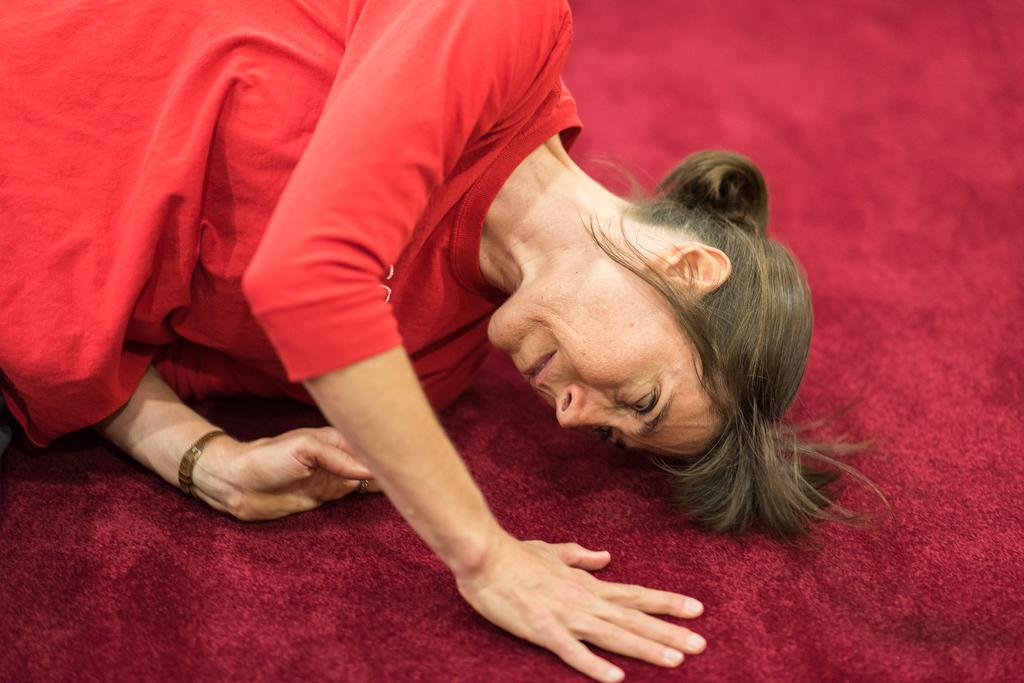Who is present in the image? There is a woman in the image. What is the woman lying on? The woman is lying on a red color mat. What is the woman wearing? The woman is wearing a red color dress. How many roses can be seen in the woman's hair in the image? There are no roses visible in the woman's hair in the image. What type of polish is the woman applying to her nails in the image? The woman is not applying any polish to her nails in the image. What unit of measurement is the woman using to determine the size of the mat in the image? The image does not show the woman using any unit of measurement to determine the size of the mat. 